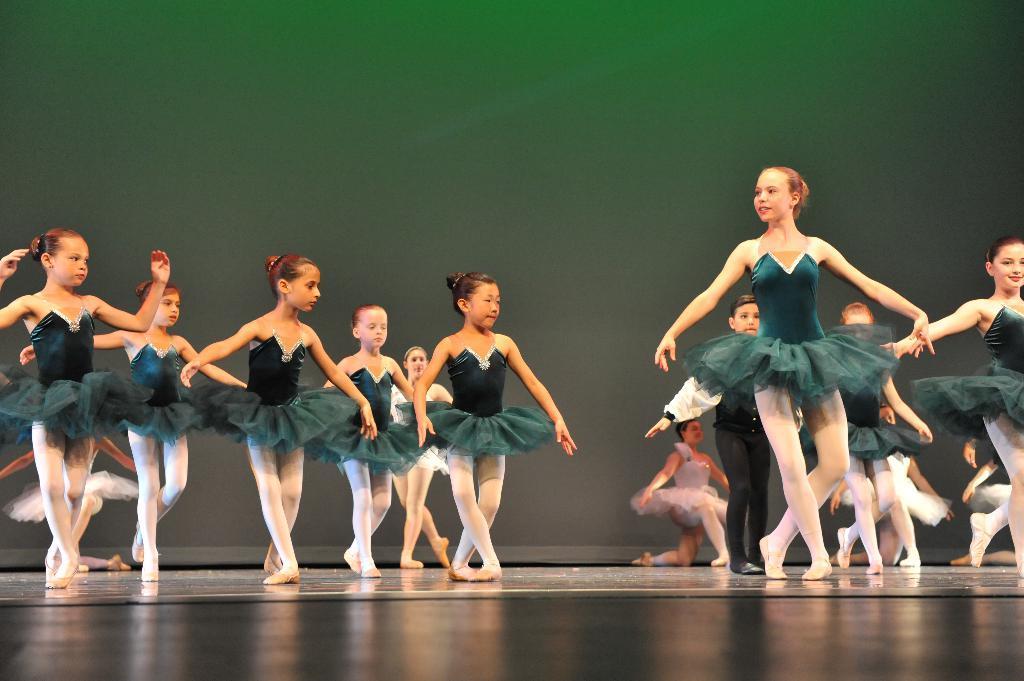Please provide a concise description of this image. In this image there are many girls performing dance. Most of them are wearing green frock. 